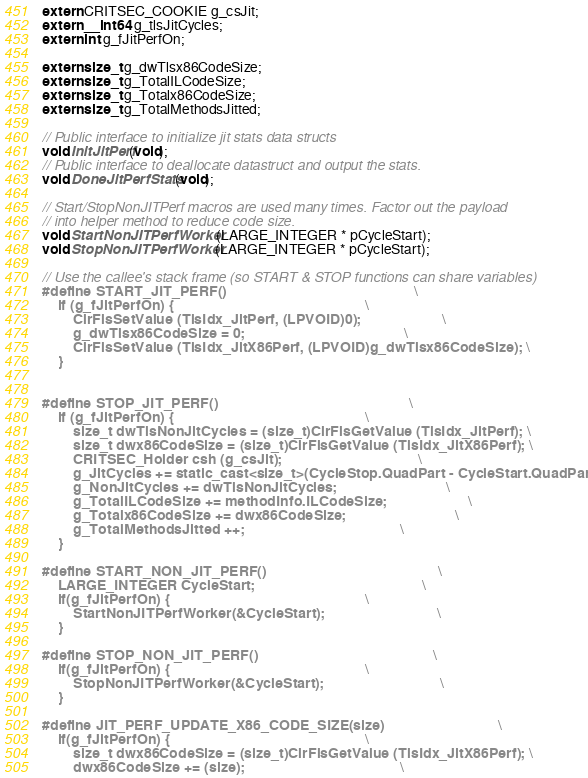<code> <loc_0><loc_0><loc_500><loc_500><_C_>extern CRITSEC_COOKIE g_csJit;
extern __int64 g_tlsJitCycles;
extern int g_fJitPerfOn;

extern size_t g_dwTlsx86CodeSize;
extern size_t g_TotalILCodeSize;
extern size_t g_Totalx86CodeSize;
extern size_t g_TotalMethodsJitted;

// Public interface to initialize jit stats data structs
void InitJitPerf(void);
// Public interface to deallocate datastruct and output the stats.
void DoneJitPerfStats(void);

// Start/StopNonJITPerf macros are used many times. Factor out the payload
// into helper method to reduce code size.
void StartNonJITPerfWorker(LARGE_INTEGER * pCycleStart);
void StopNonJITPerfWorker(LARGE_INTEGER * pCycleStart);

// Use the callee's stack frame (so START & STOP functions can share variables)
#define START_JIT_PERF()                                                \
    if (g_fJitPerfOn) {                                                 \
        ClrFlsSetValue (TlsIdx_JitPerf, (LPVOID)0);                     \
        g_dwTlsx86CodeSize = 0;                                         \
        ClrFlsSetValue (TlsIdx_JitX86Perf, (LPVOID)g_dwTlsx86CodeSize); \
    } 


#define STOP_JIT_PERF()                                                 \
    if (g_fJitPerfOn) {                                                 \
        size_t dwTlsNonJitCycles = (size_t)ClrFlsGetValue (TlsIdx_JitPerf); \
        size_t dwx86CodeSize = (size_t)ClrFlsGetValue (TlsIdx_JitX86Perf); \
        CRITSEC_Holder csh (g_csJit);                                   \
        g_JitCycles += static_cast<size_t>(CycleStop.QuadPart - CycleStart.QuadPart);      \
        g_NonJitCycles += dwTlsNonJitCycles;                            \
        g_TotalILCodeSize += methodInfo.ILCodeSize;                     \
        g_Totalx86CodeSize += dwx86CodeSize;                            \
        g_TotalMethodsJitted ++;                                        \
    }

#define START_NON_JIT_PERF()                                            \
    LARGE_INTEGER CycleStart;                                           \
    if(g_fJitPerfOn) {                                                  \
        StartNonJITPerfWorker(&CycleStart);                             \
    }

#define STOP_NON_JIT_PERF()                                             \
    if(g_fJitPerfOn) {                                                  \
        StopNonJITPerfWorker(&CycleStart);                              \
    }

#define JIT_PERF_UPDATE_X86_CODE_SIZE(size)                             \
    if(g_fJitPerfOn) {                                                  \
        size_t dwx86CodeSize = (size_t)ClrFlsGetValue (TlsIdx_JitX86Perf); \
        dwx86CodeSize += (size);                                        \</code> 